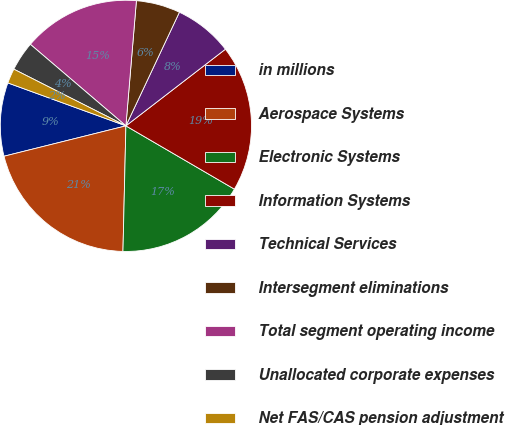Convert chart. <chart><loc_0><loc_0><loc_500><loc_500><pie_chart><fcel>in millions<fcel>Aerospace Systems<fcel>Electronic Systems<fcel>Information Systems<fcel>Technical Services<fcel>Intersegment eliminations<fcel>Total segment operating income<fcel>Unallocated corporate expenses<fcel>Net FAS/CAS pension adjustment<nl><fcel>9.44%<fcel>20.74%<fcel>16.97%<fcel>18.85%<fcel>7.55%<fcel>5.67%<fcel>15.09%<fcel>3.79%<fcel>1.9%<nl></chart> 